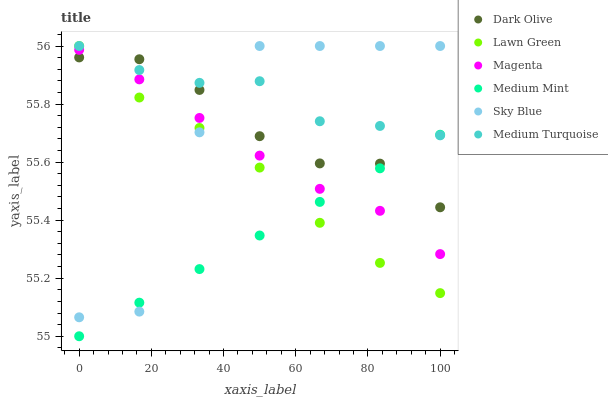Does Medium Mint have the minimum area under the curve?
Answer yes or no. Yes. Does Medium Turquoise have the maximum area under the curve?
Answer yes or no. Yes. Does Lawn Green have the minimum area under the curve?
Answer yes or no. No. Does Lawn Green have the maximum area under the curve?
Answer yes or no. No. Is Medium Mint the smoothest?
Answer yes or no. Yes. Is Sky Blue the roughest?
Answer yes or no. Yes. Is Lawn Green the smoothest?
Answer yes or no. No. Is Lawn Green the roughest?
Answer yes or no. No. Does Medium Mint have the lowest value?
Answer yes or no. Yes. Does Lawn Green have the lowest value?
Answer yes or no. No. Does Sky Blue have the highest value?
Answer yes or no. Yes. Does Dark Olive have the highest value?
Answer yes or no. No. Is Magenta less than Medium Turquoise?
Answer yes or no. Yes. Is Medium Turquoise greater than Magenta?
Answer yes or no. Yes. Does Lawn Green intersect Medium Mint?
Answer yes or no. Yes. Is Lawn Green less than Medium Mint?
Answer yes or no. No. Is Lawn Green greater than Medium Mint?
Answer yes or no. No. Does Magenta intersect Medium Turquoise?
Answer yes or no. No. 